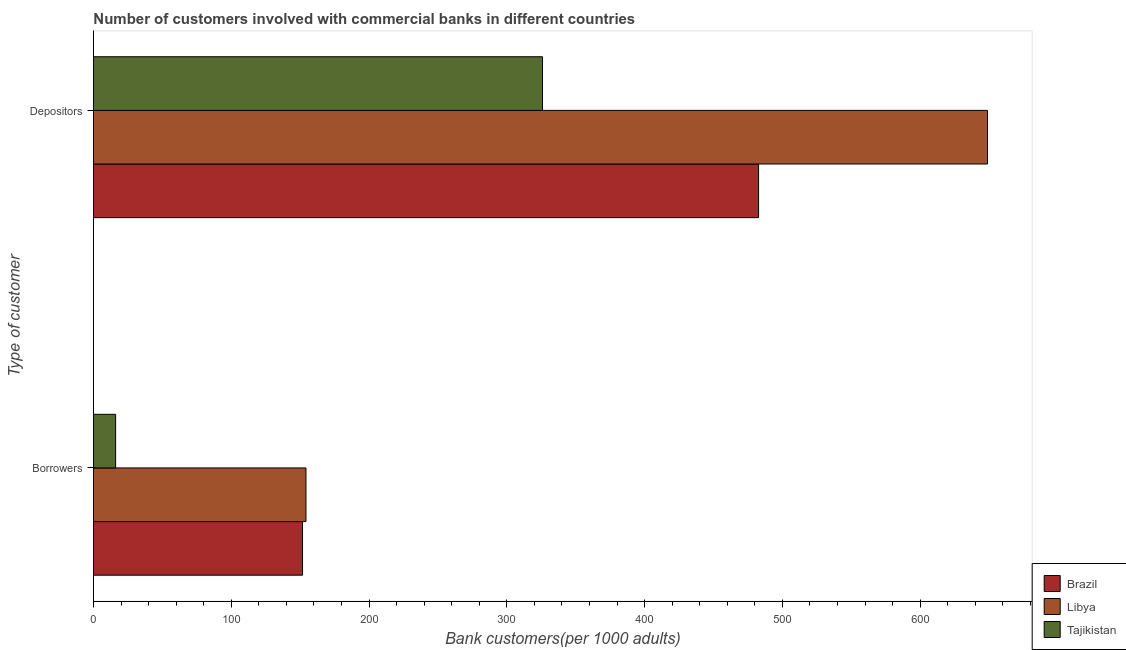How many groups of bars are there?
Provide a short and direct response. 2. Are the number of bars on each tick of the Y-axis equal?
Keep it short and to the point. Yes. How many bars are there on the 1st tick from the top?
Your answer should be compact. 3. What is the label of the 1st group of bars from the top?
Offer a very short reply. Depositors. What is the number of depositors in Tajikistan?
Ensure brevity in your answer.  325.89. Across all countries, what is the maximum number of borrowers?
Give a very brief answer. 154.22. Across all countries, what is the minimum number of borrowers?
Offer a very short reply. 16.09. In which country was the number of borrowers maximum?
Ensure brevity in your answer.  Libya. In which country was the number of depositors minimum?
Ensure brevity in your answer.  Tajikistan. What is the total number of depositors in the graph?
Your answer should be compact. 1457.49. What is the difference between the number of borrowers in Tajikistan and that in Libya?
Provide a succinct answer. -138.13. What is the difference between the number of borrowers in Libya and the number of depositors in Brazil?
Provide a short and direct response. -328.52. What is the average number of borrowers per country?
Offer a very short reply. 107.35. What is the difference between the number of depositors and number of borrowers in Tajikistan?
Ensure brevity in your answer.  309.8. In how many countries, is the number of borrowers greater than 620 ?
Your answer should be very brief. 0. What is the ratio of the number of depositors in Brazil to that in Libya?
Make the answer very short. 0.74. In how many countries, is the number of depositors greater than the average number of depositors taken over all countries?
Keep it short and to the point. 1. What does the 3rd bar from the top in Borrowers represents?
Provide a succinct answer. Brazil. What does the 2nd bar from the bottom in Depositors represents?
Make the answer very short. Libya. How many bars are there?
Give a very brief answer. 6. How many countries are there in the graph?
Offer a terse response. 3. What is the difference between two consecutive major ticks on the X-axis?
Offer a very short reply. 100. Does the graph contain any zero values?
Keep it short and to the point. No. Does the graph contain grids?
Offer a very short reply. No. How many legend labels are there?
Provide a short and direct response. 3. What is the title of the graph?
Provide a succinct answer. Number of customers involved with commercial banks in different countries. What is the label or title of the X-axis?
Your answer should be compact. Bank customers(per 1000 adults). What is the label or title of the Y-axis?
Provide a short and direct response. Type of customer. What is the Bank customers(per 1000 adults) in Brazil in Borrowers?
Make the answer very short. 151.74. What is the Bank customers(per 1000 adults) of Libya in Borrowers?
Offer a terse response. 154.22. What is the Bank customers(per 1000 adults) of Tajikistan in Borrowers?
Your answer should be compact. 16.09. What is the Bank customers(per 1000 adults) in Brazil in Depositors?
Offer a terse response. 482.74. What is the Bank customers(per 1000 adults) in Libya in Depositors?
Offer a terse response. 648.86. What is the Bank customers(per 1000 adults) of Tajikistan in Depositors?
Your response must be concise. 325.89. Across all Type of customer, what is the maximum Bank customers(per 1000 adults) of Brazil?
Offer a terse response. 482.74. Across all Type of customer, what is the maximum Bank customers(per 1000 adults) of Libya?
Your answer should be very brief. 648.86. Across all Type of customer, what is the maximum Bank customers(per 1000 adults) in Tajikistan?
Offer a very short reply. 325.89. Across all Type of customer, what is the minimum Bank customers(per 1000 adults) in Brazil?
Ensure brevity in your answer.  151.74. Across all Type of customer, what is the minimum Bank customers(per 1000 adults) of Libya?
Your answer should be very brief. 154.22. Across all Type of customer, what is the minimum Bank customers(per 1000 adults) in Tajikistan?
Ensure brevity in your answer.  16.09. What is the total Bank customers(per 1000 adults) in Brazil in the graph?
Make the answer very short. 634.48. What is the total Bank customers(per 1000 adults) of Libya in the graph?
Keep it short and to the point. 803.08. What is the total Bank customers(per 1000 adults) of Tajikistan in the graph?
Provide a succinct answer. 341.98. What is the difference between the Bank customers(per 1000 adults) of Brazil in Borrowers and that in Depositors?
Give a very brief answer. -331. What is the difference between the Bank customers(per 1000 adults) of Libya in Borrowers and that in Depositors?
Keep it short and to the point. -494.64. What is the difference between the Bank customers(per 1000 adults) of Tajikistan in Borrowers and that in Depositors?
Provide a short and direct response. -309.8. What is the difference between the Bank customers(per 1000 adults) of Brazil in Borrowers and the Bank customers(per 1000 adults) of Libya in Depositors?
Offer a terse response. -497.12. What is the difference between the Bank customers(per 1000 adults) in Brazil in Borrowers and the Bank customers(per 1000 adults) in Tajikistan in Depositors?
Give a very brief answer. -174.15. What is the difference between the Bank customers(per 1000 adults) of Libya in Borrowers and the Bank customers(per 1000 adults) of Tajikistan in Depositors?
Ensure brevity in your answer.  -171.67. What is the average Bank customers(per 1000 adults) of Brazil per Type of customer?
Provide a succinct answer. 317.24. What is the average Bank customers(per 1000 adults) in Libya per Type of customer?
Your answer should be compact. 401.54. What is the average Bank customers(per 1000 adults) of Tajikistan per Type of customer?
Keep it short and to the point. 170.99. What is the difference between the Bank customers(per 1000 adults) in Brazil and Bank customers(per 1000 adults) in Libya in Borrowers?
Offer a very short reply. -2.48. What is the difference between the Bank customers(per 1000 adults) of Brazil and Bank customers(per 1000 adults) of Tajikistan in Borrowers?
Give a very brief answer. 135.65. What is the difference between the Bank customers(per 1000 adults) in Libya and Bank customers(per 1000 adults) in Tajikistan in Borrowers?
Provide a short and direct response. 138.13. What is the difference between the Bank customers(per 1000 adults) in Brazil and Bank customers(per 1000 adults) in Libya in Depositors?
Provide a succinct answer. -166.12. What is the difference between the Bank customers(per 1000 adults) in Brazil and Bank customers(per 1000 adults) in Tajikistan in Depositors?
Provide a succinct answer. 156.85. What is the difference between the Bank customers(per 1000 adults) of Libya and Bank customers(per 1000 adults) of Tajikistan in Depositors?
Offer a very short reply. 322.97. What is the ratio of the Bank customers(per 1000 adults) of Brazil in Borrowers to that in Depositors?
Keep it short and to the point. 0.31. What is the ratio of the Bank customers(per 1000 adults) of Libya in Borrowers to that in Depositors?
Provide a succinct answer. 0.24. What is the ratio of the Bank customers(per 1000 adults) of Tajikistan in Borrowers to that in Depositors?
Offer a very short reply. 0.05. What is the difference between the highest and the second highest Bank customers(per 1000 adults) in Brazil?
Offer a very short reply. 331. What is the difference between the highest and the second highest Bank customers(per 1000 adults) in Libya?
Your response must be concise. 494.64. What is the difference between the highest and the second highest Bank customers(per 1000 adults) in Tajikistan?
Make the answer very short. 309.8. What is the difference between the highest and the lowest Bank customers(per 1000 adults) of Brazil?
Ensure brevity in your answer.  331. What is the difference between the highest and the lowest Bank customers(per 1000 adults) of Libya?
Provide a short and direct response. 494.64. What is the difference between the highest and the lowest Bank customers(per 1000 adults) of Tajikistan?
Keep it short and to the point. 309.8. 